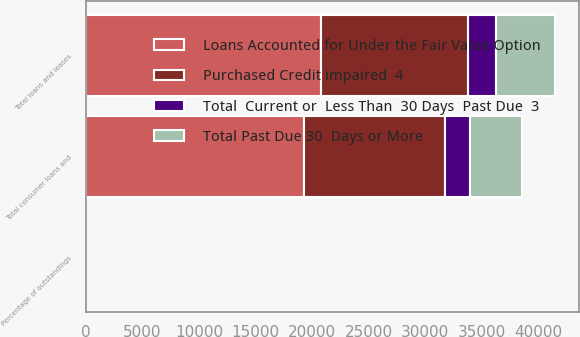<chart> <loc_0><loc_0><loc_500><loc_500><stacked_bar_chart><ecel><fcel>Total consumer loans and<fcel>Total loans and leases<fcel>Percentage of outstandings<nl><fcel>Total Past Due 30  Days or More<fcel>4532<fcel>5270<fcel>0.59<nl><fcel>Total  Current or  Less Than  30 Days  Past Due  3<fcel>2230<fcel>2463<fcel>0.27<nl><fcel>Purchased Credit impaired  4<fcel>12513<fcel>13022<fcel>1.44<nl><fcel>Loans Accounted for Under the Fair Value Option<fcel>19275<fcel>20755<fcel>2.3<nl></chart> 